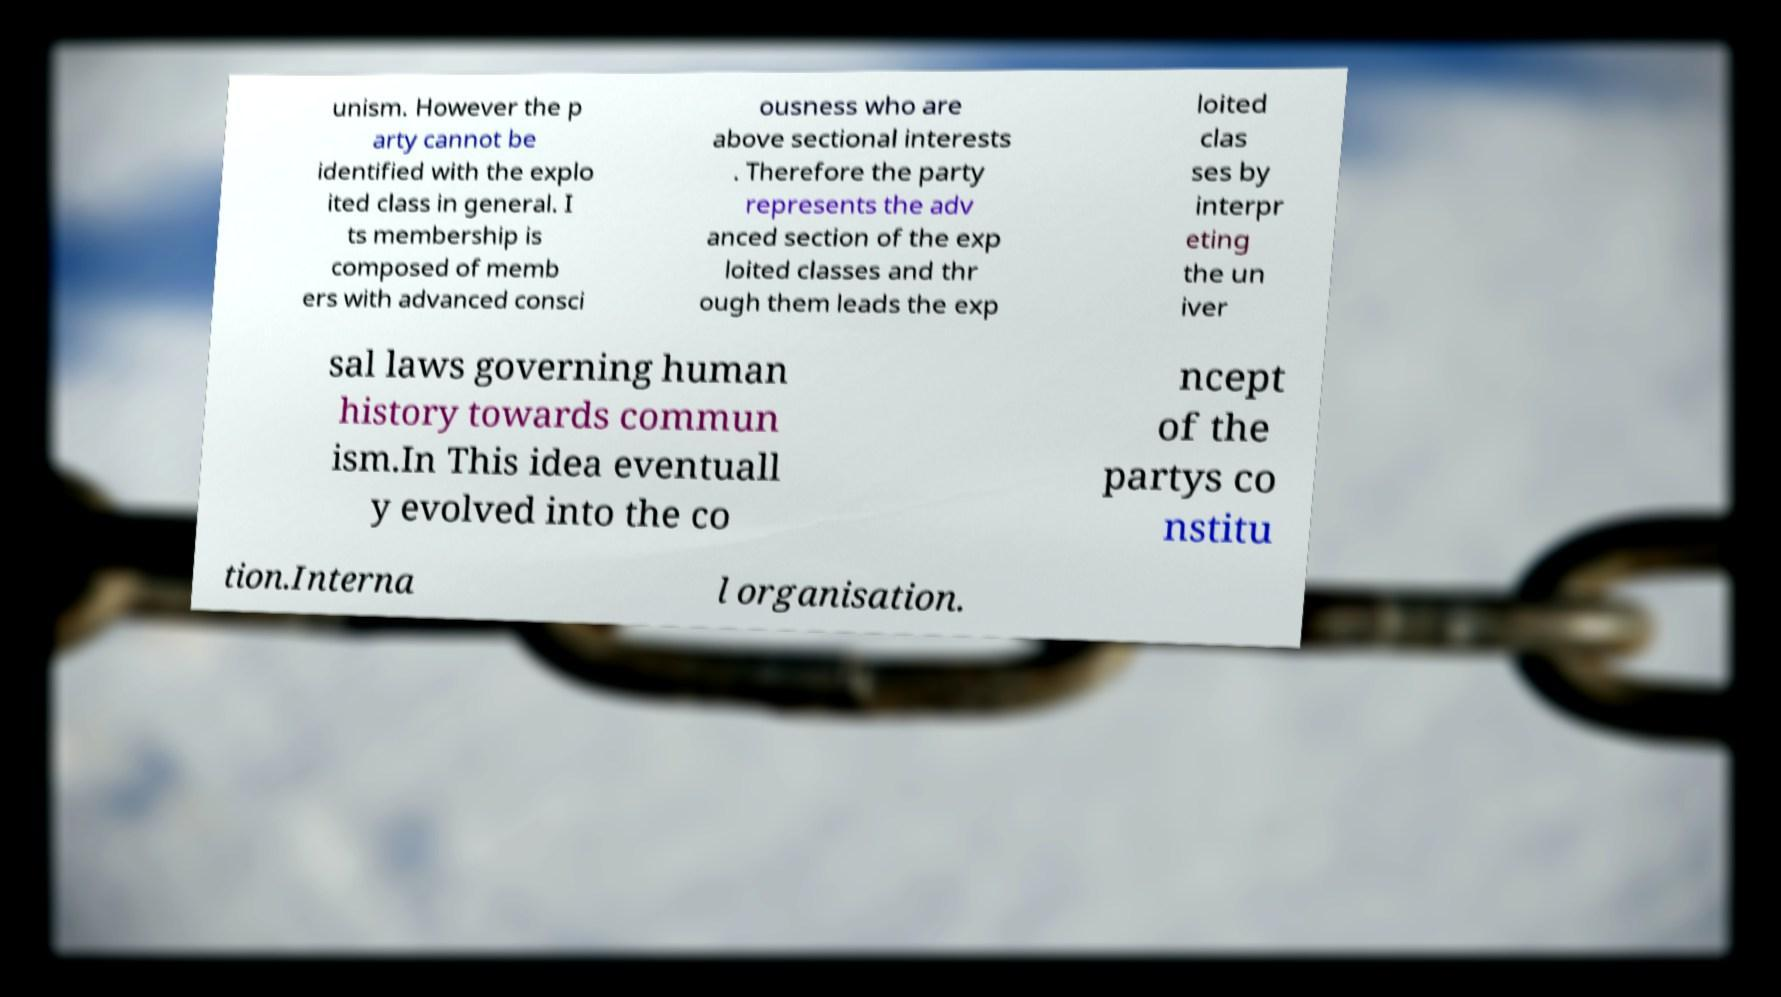What messages or text are displayed in this image? I need them in a readable, typed format. unism. However the p arty cannot be identified with the explo ited class in general. I ts membership is composed of memb ers with advanced consci ousness who are above sectional interests . Therefore the party represents the adv anced section of the exp loited classes and thr ough them leads the exp loited clas ses by interpr eting the un iver sal laws governing human history towards commun ism.In This idea eventuall y evolved into the co ncept of the partys co nstitu tion.Interna l organisation. 